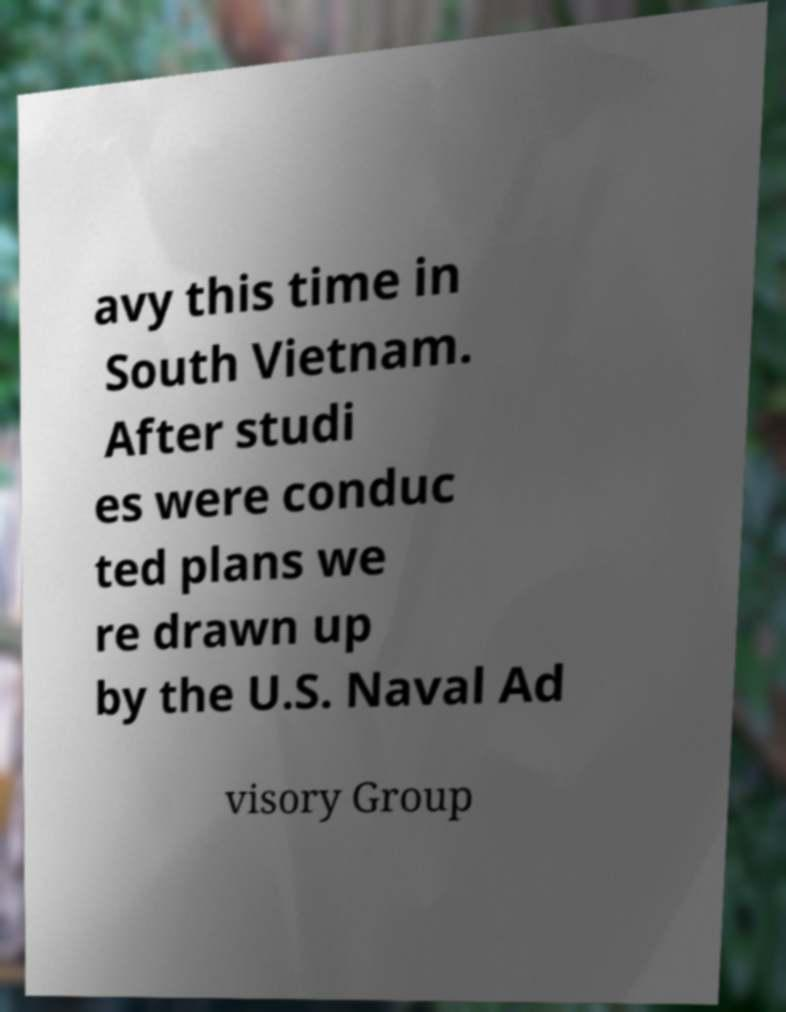Can you accurately transcribe the text from the provided image for me? avy this time in South Vietnam. After studi es were conduc ted plans we re drawn up by the U.S. Naval Ad visory Group 